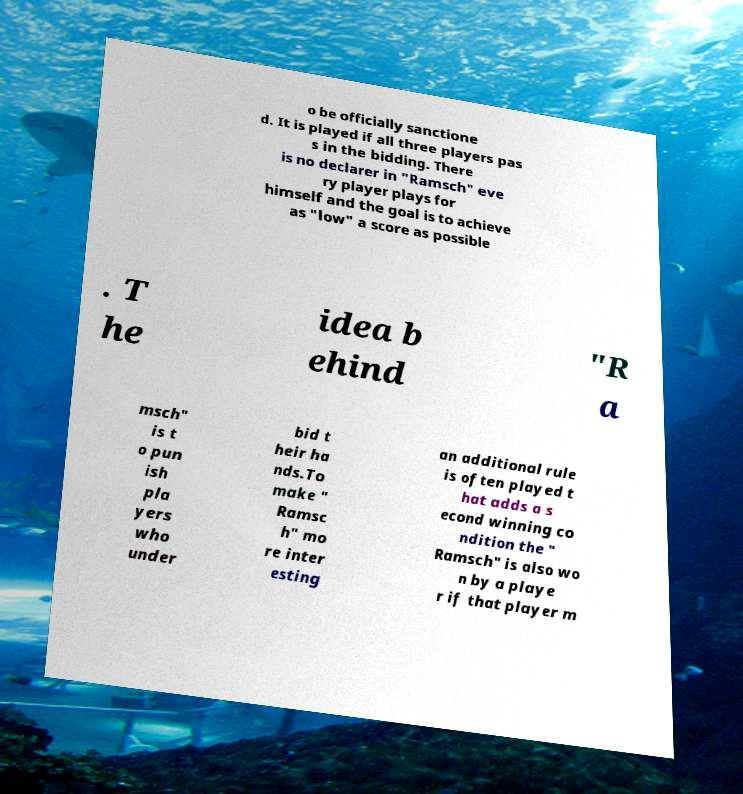Can you read and provide the text displayed in the image?This photo seems to have some interesting text. Can you extract and type it out for me? o be officially sanctione d. It is played if all three players pas s in the bidding. There is no declarer in "Ramsch" eve ry player plays for himself and the goal is to achieve as "low" a score as possible . T he idea b ehind "R a msch" is t o pun ish pla yers who under bid t heir ha nds.To make " Ramsc h" mo re inter esting an additional rule is often played t hat adds a s econd winning co ndition the " Ramsch" is also wo n by a playe r if that player m 